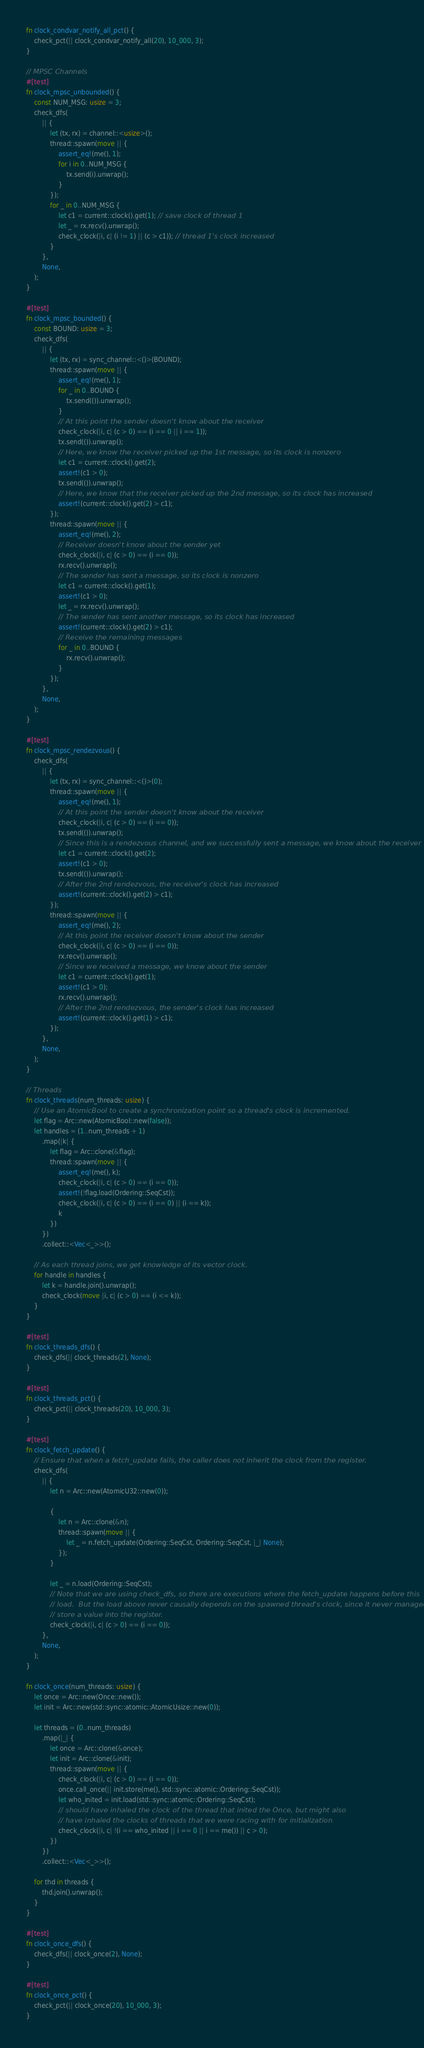Convert code to text. <code><loc_0><loc_0><loc_500><loc_500><_Rust_>fn clock_condvar_notify_all_pct() {
    check_pct(|| clock_condvar_notify_all(20), 10_000, 3);
}

// MPSC Channels
#[test]
fn clock_mpsc_unbounded() {
    const NUM_MSG: usize = 3;
    check_dfs(
        || {
            let (tx, rx) = channel::<usize>();
            thread::spawn(move || {
                assert_eq!(me(), 1);
                for i in 0..NUM_MSG {
                    tx.send(i).unwrap();
                }
            });
            for _ in 0..NUM_MSG {
                let c1 = current::clock().get(1); // save clock of thread 1
                let _ = rx.recv().unwrap();
                check_clock(|i, c| (i != 1) || (c > c1)); // thread 1's clock increased
            }
        },
        None,
    );
}

#[test]
fn clock_mpsc_bounded() {
    const BOUND: usize = 3;
    check_dfs(
        || {
            let (tx, rx) = sync_channel::<()>(BOUND);
            thread::spawn(move || {
                assert_eq!(me(), 1);
                for _ in 0..BOUND {
                    tx.send(()).unwrap();
                }
                // At this point the sender doesn't know about the receiver
                check_clock(|i, c| (c > 0) == (i == 0 || i == 1));
                tx.send(()).unwrap();
                // Here, we know the receiver picked up the 1st message, so its clock is nonzero
                let c1 = current::clock().get(2);
                assert!(c1 > 0);
                tx.send(()).unwrap();
                // Here, we know that the receiver picked up the 2nd message, so its clock has increased
                assert!(current::clock().get(2) > c1);
            });
            thread::spawn(move || {
                assert_eq!(me(), 2);
                // Receiver doesn't know about the sender yet
                check_clock(|i, c| (c > 0) == (i == 0));
                rx.recv().unwrap();
                // The sender has sent a message, so its clock is nonzero
                let c1 = current::clock().get(1);
                assert!(c1 > 0);
                let _ = rx.recv().unwrap();
                // The sender has sent another message, so its clock has increased
                assert!(current::clock().get(2) > c1);
                // Receive the remaining messages
                for _ in 0..BOUND {
                    rx.recv().unwrap();
                }
            });
        },
        None,
    );
}

#[test]
fn clock_mpsc_rendezvous() {
    check_dfs(
        || {
            let (tx, rx) = sync_channel::<()>(0);
            thread::spawn(move || {
                assert_eq!(me(), 1);
                // At this point the sender doesn't know about the receiver
                check_clock(|i, c| (c > 0) == (i == 0));
                tx.send(()).unwrap();
                // Since this is a rendezvous channel, and we successfully sent a message, we know about the receiver
                let c1 = current::clock().get(2);
                assert!(c1 > 0);
                tx.send(()).unwrap();
                // After the 2nd rendezvous, the receiver's clock has increased
                assert!(current::clock().get(2) > c1);
            });
            thread::spawn(move || {
                assert_eq!(me(), 2);
                // At this point the receiver doesn't know about the sender
                check_clock(|i, c| (c > 0) == (i == 0));
                rx.recv().unwrap();
                // Since we received a message, we know about the sender
                let c1 = current::clock().get(1);
                assert!(c1 > 0);
                rx.recv().unwrap();
                // After the 2nd rendezvous, the sender's clock has increased
                assert!(current::clock().get(1) > c1);
            });
        },
        None,
    );
}

// Threads
fn clock_threads(num_threads: usize) {
    // Use an AtomicBool to create a synchronization point so a thread's clock is incremented.
    let flag = Arc::new(AtomicBool::new(false));
    let handles = (1..num_threads + 1)
        .map(|k| {
            let flag = Arc::clone(&flag);
            thread::spawn(move || {
                assert_eq!(me(), k);
                check_clock(|i, c| (c > 0) == (i == 0));
                assert!(!flag.load(Ordering::SeqCst));
                check_clock(|i, c| (c > 0) == (i == 0) || (i == k));
                k
            })
        })
        .collect::<Vec<_>>();

    // As each thread joins, we get knowledge of its vector clock.
    for handle in handles {
        let k = handle.join().unwrap();
        check_clock(move |i, c| (c > 0) == (i <= k));
    }
}

#[test]
fn clock_threads_dfs() {
    check_dfs(|| clock_threads(2), None);
}

#[test]
fn clock_threads_pct() {
    check_pct(|| clock_threads(20), 10_000, 3);
}

#[test]
fn clock_fetch_update() {
    // Ensure that when a fetch_update fails, the caller does not inherit the clock from the register.
    check_dfs(
        || {
            let n = Arc::new(AtomicU32::new(0));

            {
                let n = Arc::clone(&n);
                thread::spawn(move || {
                    let _ = n.fetch_update(Ordering::SeqCst, Ordering::SeqCst, |_| None);
                });
            }

            let _ = n.load(Ordering::SeqCst);
            // Note that we are using check_dfs, so there are executions where the fetch_update happens before this
            // load.  But the load above never causally depends on the spawned thread's clock, since it never managed to
            // store a value into the register.
            check_clock(|i, c| (c > 0) == (i == 0));
        },
        None,
    );
}

fn clock_once(num_threads: usize) {
    let once = Arc::new(Once::new());
    let init = Arc::new(std::sync::atomic::AtomicUsize::new(0));

    let threads = (0..num_threads)
        .map(|_| {
            let once = Arc::clone(&once);
            let init = Arc::clone(&init);
            thread::spawn(move || {
                check_clock(|i, c| (c > 0) == (i == 0));
                once.call_once(|| init.store(me(), std::sync::atomic::Ordering::SeqCst));
                let who_inited = init.load(std::sync::atomic::Ordering::SeqCst);
                // should have inhaled the clock of the thread that inited the Once, but might also
                // have inhaled the clocks of threads that we were racing with for initialization
                check_clock(|i, c| !(i == who_inited || i == 0 || i == me()) || c > 0);
            })
        })
        .collect::<Vec<_>>();

    for thd in threads {
        thd.join().unwrap();
    }
}

#[test]
fn clock_once_dfs() {
    check_dfs(|| clock_once(2), None);
}

#[test]
fn clock_once_pct() {
    check_pct(|| clock_once(20), 10_000, 3);
}
</code> 